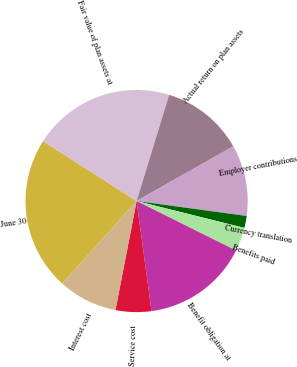<chart> <loc_0><loc_0><loc_500><loc_500><pie_chart><fcel>June 30<fcel>Fair value of plan assets at<fcel>Actual return on plan assets<fcel>Employer contributions<fcel>Currency translation<fcel>Benefits paid<fcel>Benefit obligation at<fcel>Service cost<fcel>Interest cost<nl><fcel>22.39%<fcel>20.67%<fcel>12.07%<fcel>10.35%<fcel>1.74%<fcel>3.46%<fcel>15.51%<fcel>5.19%<fcel>8.63%<nl></chart> 